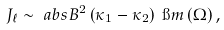Convert formula to latex. <formula><loc_0><loc_0><loc_500><loc_500>J _ { \ell } & \sim \ a b s { B } ^ { 2 } \left ( \kappa _ { 1 } - \kappa _ { 2 } \right ) \ \i m \left ( \Omega \right ) ,</formula> 